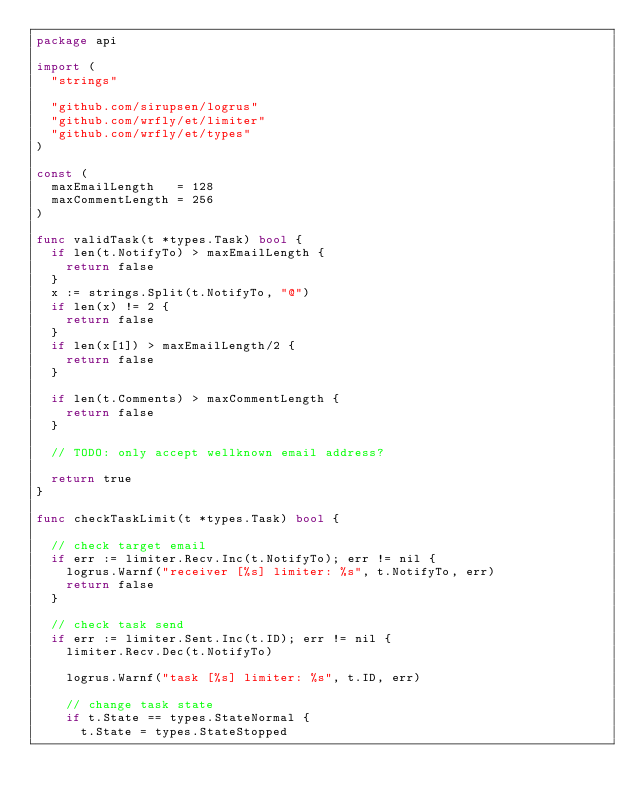Convert code to text. <code><loc_0><loc_0><loc_500><loc_500><_Go_>package api

import (
	"strings"

	"github.com/sirupsen/logrus"
	"github.com/wrfly/et/limiter"
	"github.com/wrfly/et/types"
)

const (
	maxEmailLength   = 128
	maxCommentLength = 256
)

func validTask(t *types.Task) bool {
	if len(t.NotifyTo) > maxEmailLength {
		return false
	}
	x := strings.Split(t.NotifyTo, "@")
	if len(x) != 2 {
		return false
	}
	if len(x[1]) > maxEmailLength/2 {
		return false
	}

	if len(t.Comments) > maxCommentLength {
		return false
	}

	// TODO: only accept wellknown email address?

	return true
}

func checkTaskLimit(t *types.Task) bool {

	// check target email
	if err := limiter.Recv.Inc(t.NotifyTo); err != nil {
		logrus.Warnf("receiver [%s] limiter: %s", t.NotifyTo, err)
		return false
	}

	// check task send
	if err := limiter.Sent.Inc(t.ID); err != nil {
		limiter.Recv.Dec(t.NotifyTo)

		logrus.Warnf("task [%s] limiter: %s", t.ID, err)

		// change task state
		if t.State == types.StateNormal {
			t.State = types.StateStopped</code> 